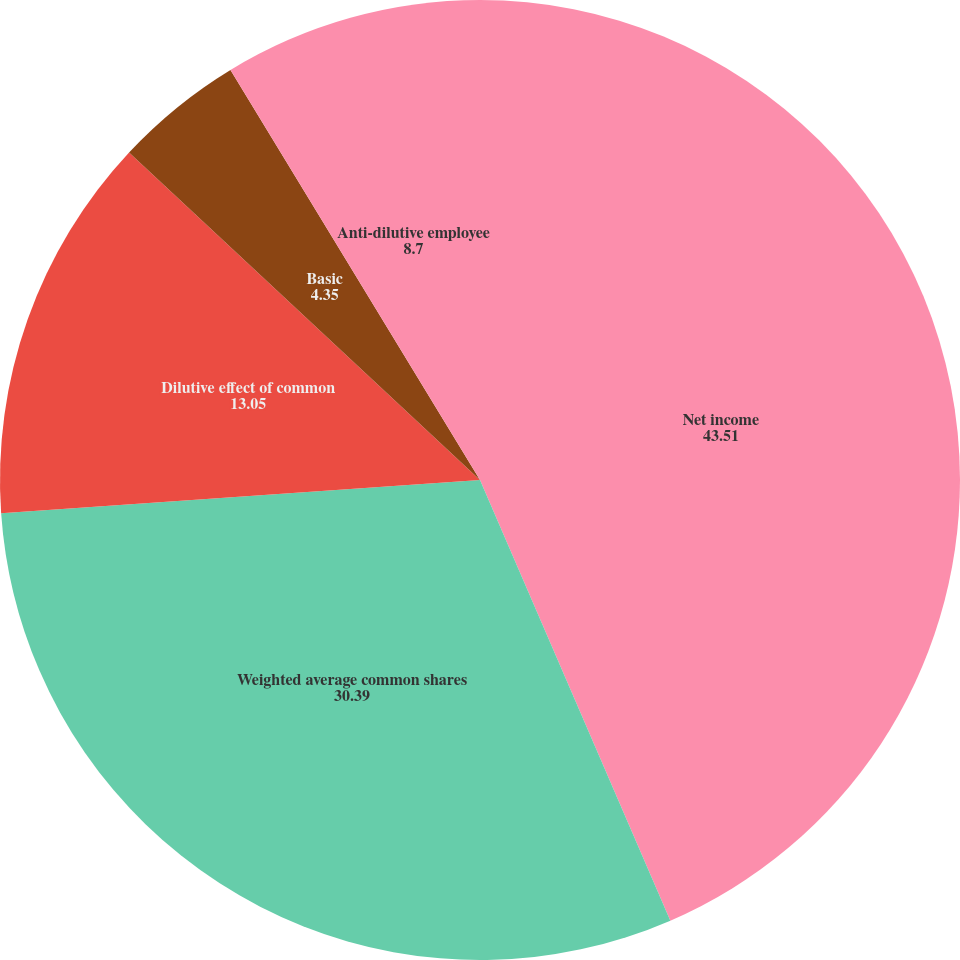Convert chart. <chart><loc_0><loc_0><loc_500><loc_500><pie_chart><fcel>Net income<fcel>Weighted average common shares<fcel>Dilutive effect of common<fcel>Basic<fcel>Diluted<fcel>Anti-dilutive employee<nl><fcel>43.51%<fcel>30.39%<fcel>13.05%<fcel>4.35%<fcel>0.0%<fcel>8.7%<nl></chart> 